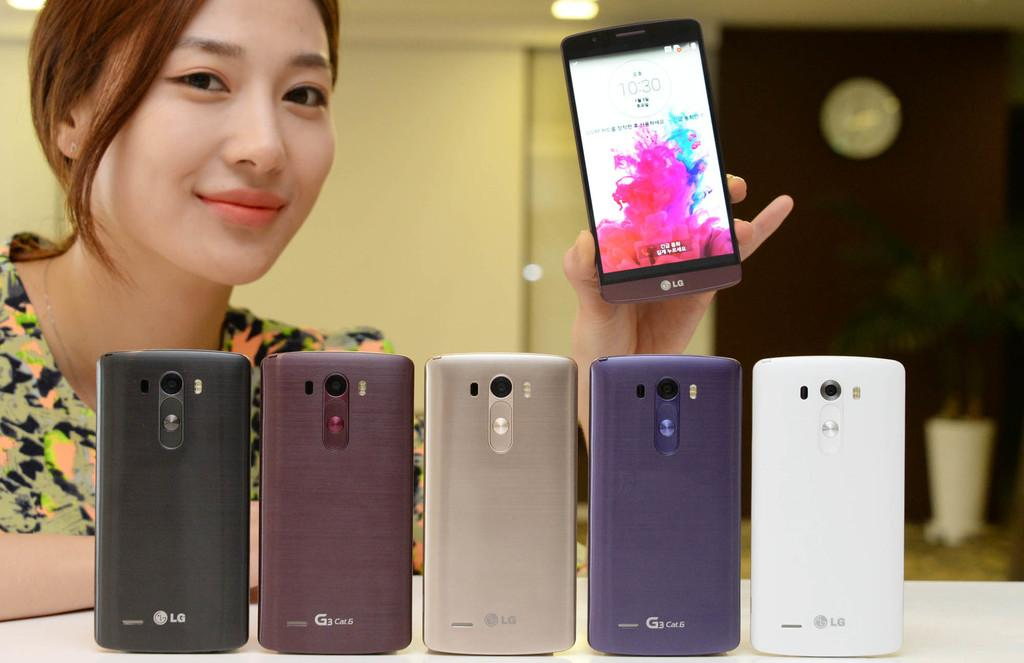<image>
Write a terse but informative summary of the picture. LG smart phones are available in several colors. 